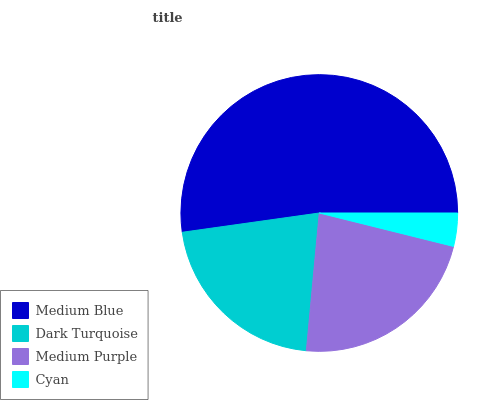Is Cyan the minimum?
Answer yes or no. Yes. Is Medium Blue the maximum?
Answer yes or no. Yes. Is Dark Turquoise the minimum?
Answer yes or no. No. Is Dark Turquoise the maximum?
Answer yes or no. No. Is Medium Blue greater than Dark Turquoise?
Answer yes or no. Yes. Is Dark Turquoise less than Medium Blue?
Answer yes or no. Yes. Is Dark Turquoise greater than Medium Blue?
Answer yes or no. No. Is Medium Blue less than Dark Turquoise?
Answer yes or no. No. Is Medium Purple the high median?
Answer yes or no. Yes. Is Dark Turquoise the low median?
Answer yes or no. Yes. Is Cyan the high median?
Answer yes or no. No. Is Medium Purple the low median?
Answer yes or no. No. 